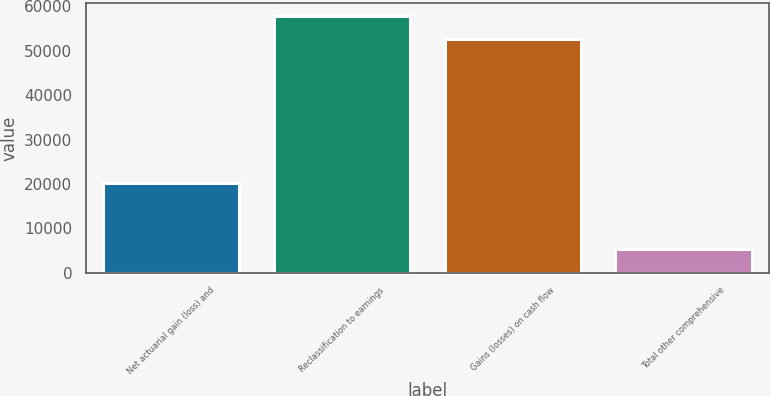Convert chart to OTSL. <chart><loc_0><loc_0><loc_500><loc_500><bar_chart><fcel>Net actuarial gain (loss) and<fcel>Reclassification to earnings<fcel>Gains (losses) on cash flow<fcel>Total other comprehensive<nl><fcel>20304<fcel>57836.1<fcel>52708<fcel>5323<nl></chart> 